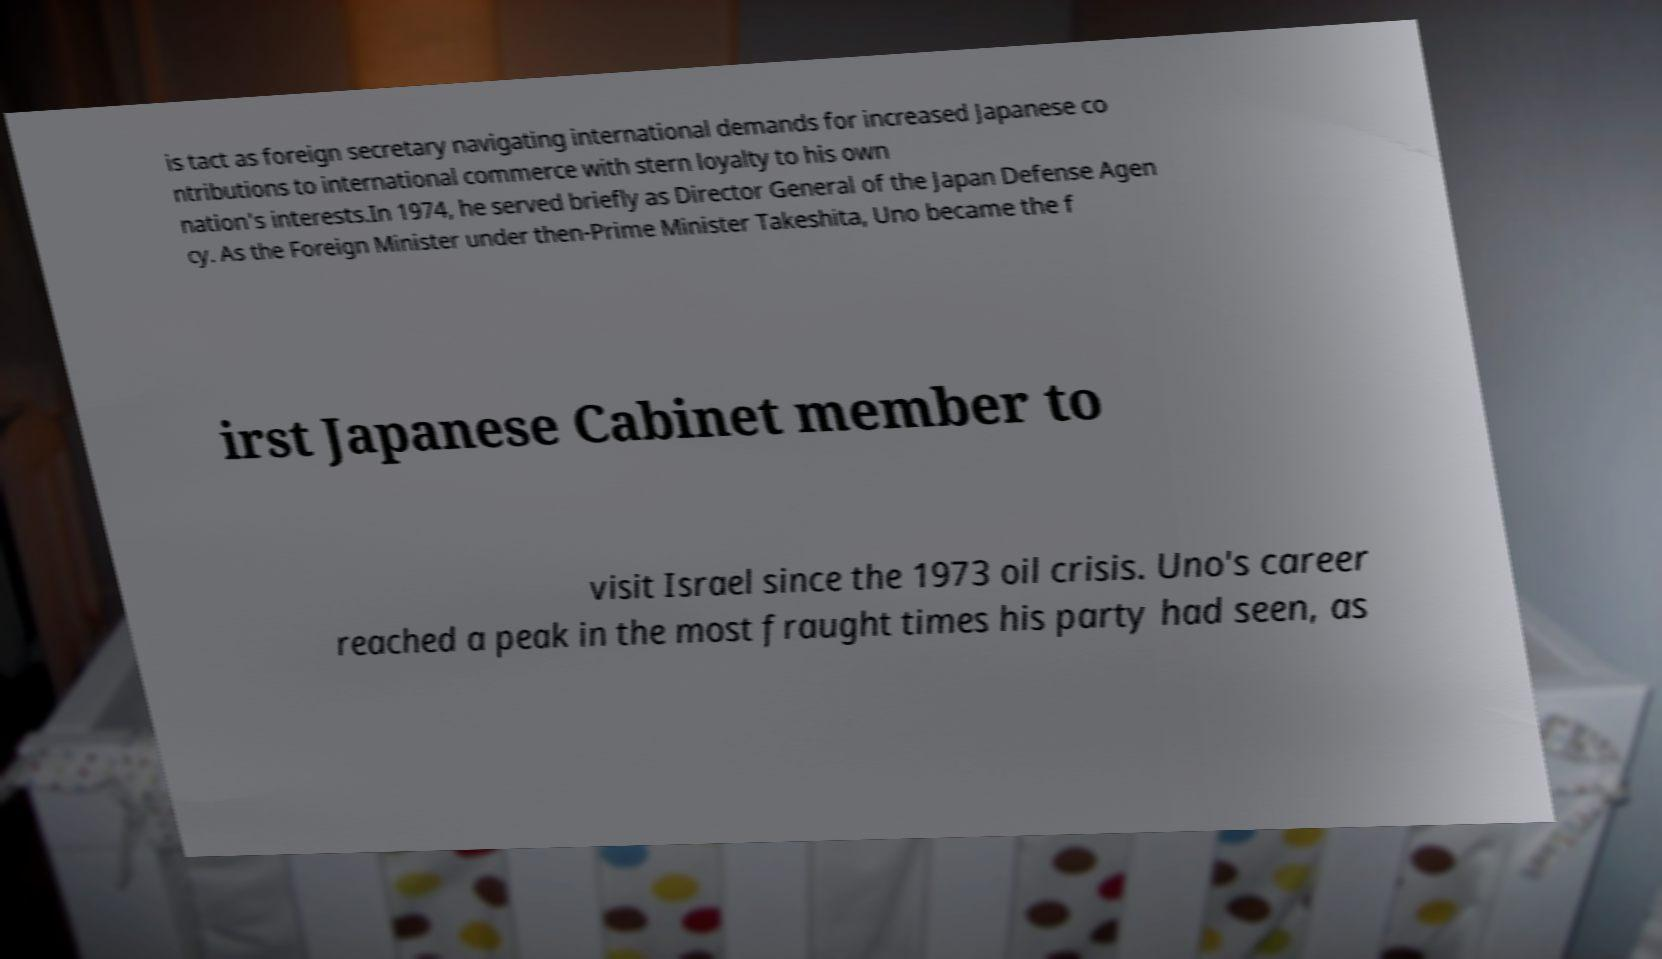Please identify and transcribe the text found in this image. is tact as foreign secretary navigating international demands for increased Japanese co ntributions to international commerce with stern loyalty to his own nation's interests.In 1974, he served briefly as Director General of the Japan Defense Agen cy. As the Foreign Minister under then-Prime Minister Takeshita, Uno became the f irst Japanese Cabinet member to visit Israel since the 1973 oil crisis. Uno's career reached a peak in the most fraught times his party had seen, as 